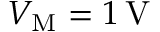Convert formula to latex. <formula><loc_0><loc_0><loc_500><loc_500>V _ { M } = 1 \, \mathrm V</formula> 